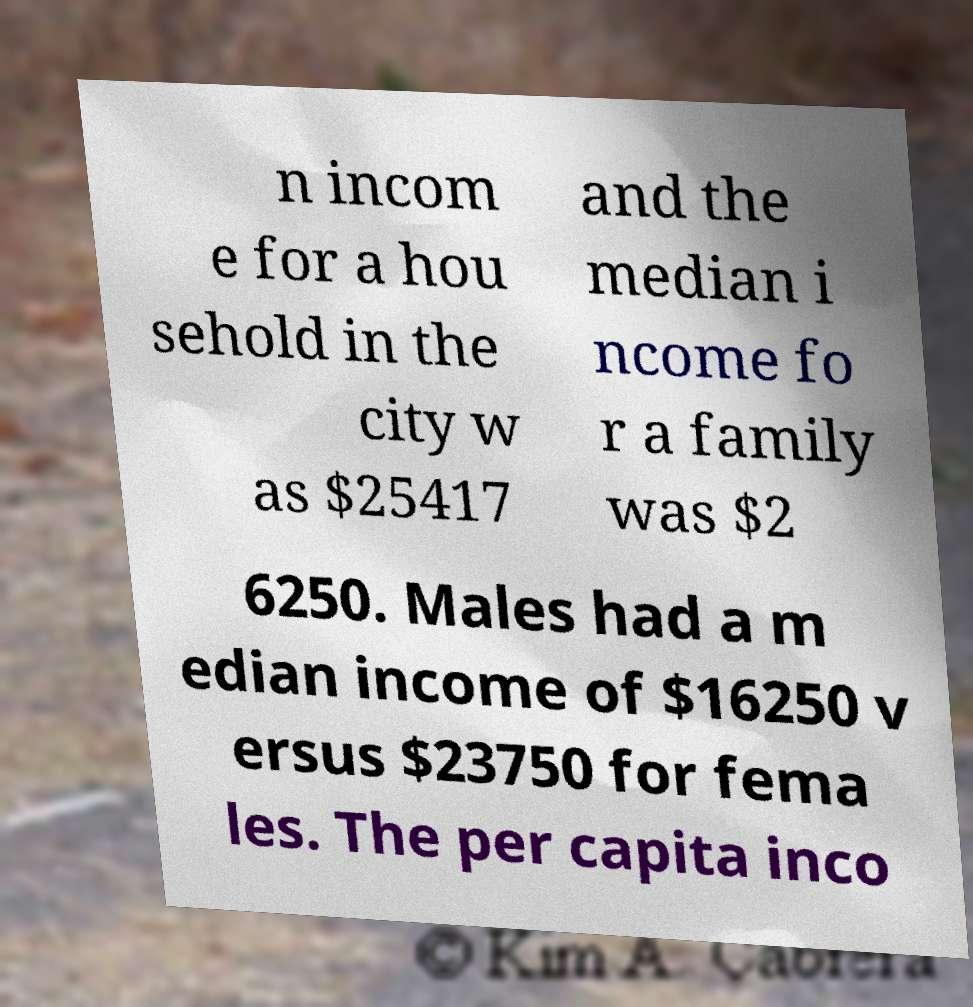Could you extract and type out the text from this image? n incom e for a hou sehold in the city w as $25417 and the median i ncome fo r a family was $2 6250. Males had a m edian income of $16250 v ersus $23750 for fema les. The per capita inco 